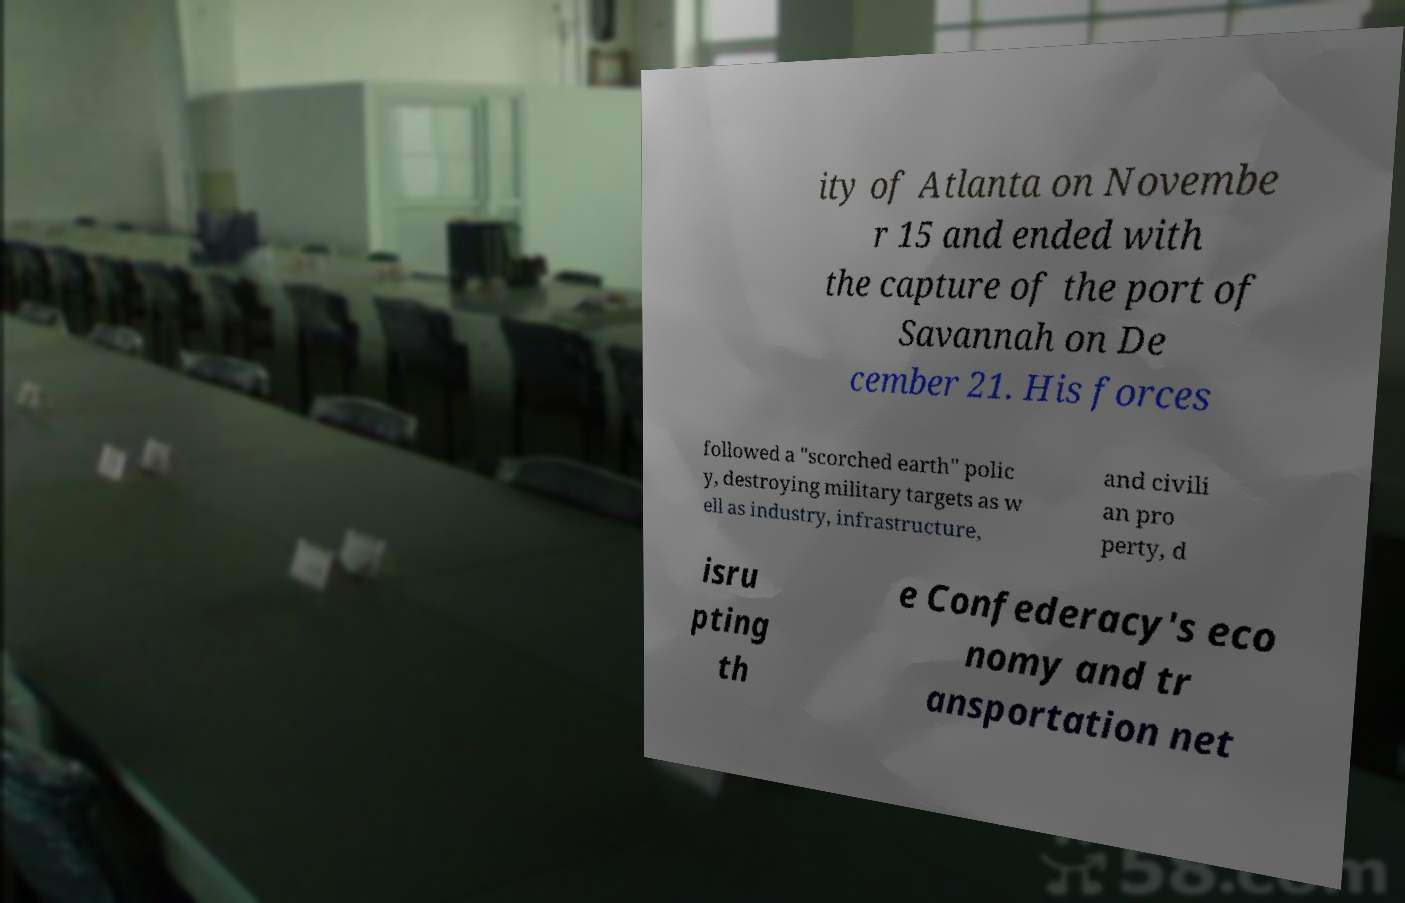Can you accurately transcribe the text from the provided image for me? ity of Atlanta on Novembe r 15 and ended with the capture of the port of Savannah on De cember 21. His forces followed a "scorched earth" polic y, destroying military targets as w ell as industry, infrastructure, and civili an pro perty, d isru pting th e Confederacy's eco nomy and tr ansportation net 